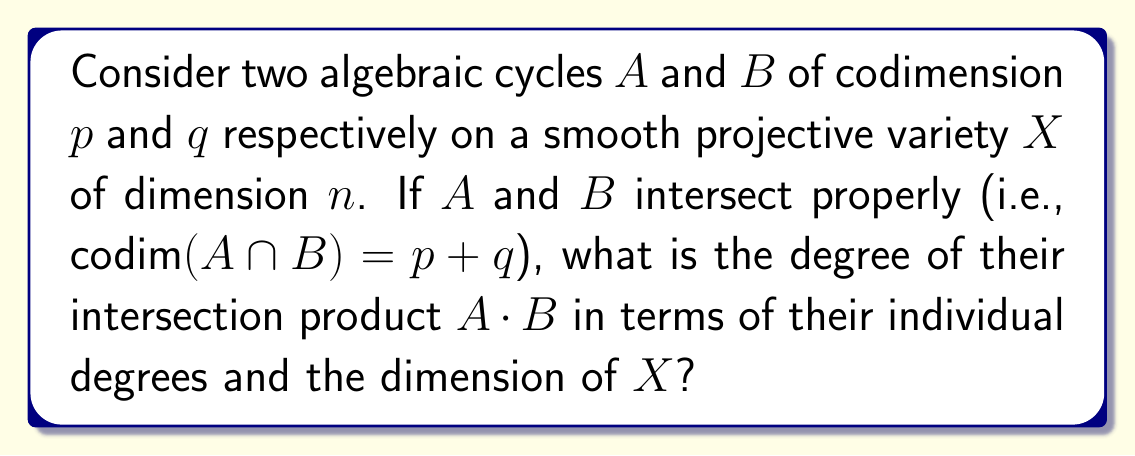Can you solve this math problem? Let's approach this step-by-step:

1) First, recall that for a smooth projective variety $X$ of dimension $n$, the intersection product of two cycles $A$ and $B$ of codimensions $p$ and $q$ respectively is defined when $A$ and $B$ intersect properly, i.e., when $\text{codim}(A \cap B) = p + q$.

2) The degree of a cycle $C$ on $X$ is defined as the number of points in which $C$ intersects a general linear subspace of complementary dimension. In other words:

   $\deg(C) = C \cdot H^{\text{codim}(C)}$

   where $H$ is the hyperplane class.

3) Now, let's consider the intersection product $A \cdot B$. This is a cycle of codimension $p + q$.

4) By the properties of intersection products, we have:

   $\deg(A \cdot B) = (A \cdot B) \cdot H^{n-p-q}$

5) Using the associativity of intersection products:

   $(A \cdot B) \cdot H^{n-p-q} = A \cdot (B \cdot H^{n-p-q})$

6) Now, $B \cdot H^{n-p-q}$ is a cycle of codimension $n-p$, which is complementary to the codimension of $A$. Therefore:

   $A \cdot (B \cdot H^{n-p-q}) = \deg(A) \cdot (B \cdot H^{n-p-q})$

7) Similarly, $B \cdot H^{n-p-q} = \deg(B) \cdot H^{n-p}$

8) Putting this all together:

   $\deg(A \cdot B) = \deg(A) \cdot \deg(B) \cdot (H^n)$

9) The term $H^n$ is actually the degree of $X$ itself, often denoted as $\deg(X)$.

Therefore, we conclude that:

$\deg(A \cdot B) = \deg(A) \cdot \deg(B) \cdot \deg(X)$
Answer: $\deg(A \cdot B) = \deg(A) \cdot \deg(B) \cdot \deg(X)$ 